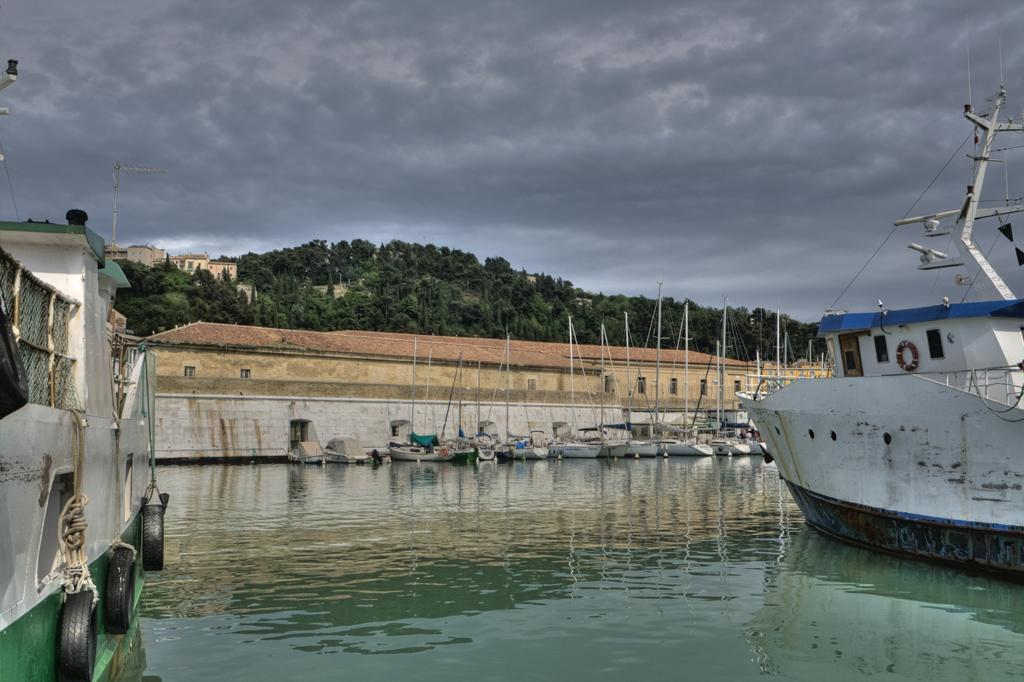What is floating on the water in the image? There are boats floating on the water in the image. What can be seen in the background of the image? There are houses, a wall, trees, and a cloudy sky in the background of the image. What type of eggnog can be seen in the image? There is no eggnog present in the image. How many birds can be seen in the image? There are no birds visible in the image. 